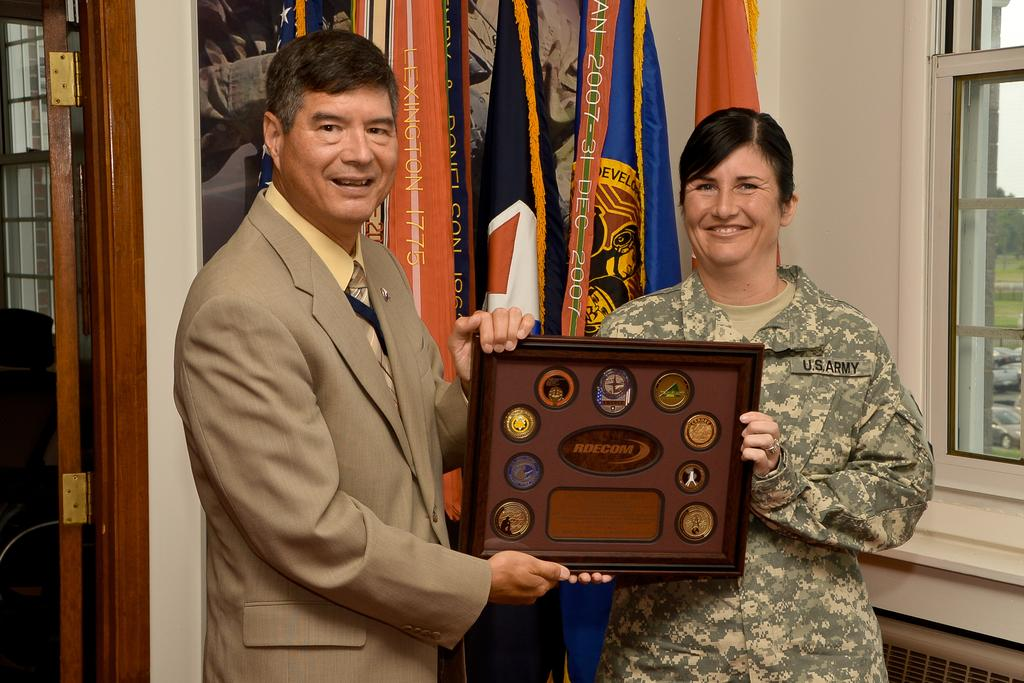How many people are present in the image? There are two people, a man and a woman, present in the image. What are the man and woman doing in the image? They are standing on the floor and holding a momento. What can be seen on the backside of the image? There are flags visible and a painting on a wall on the backside. Is there any architectural feature present in the image? Yes, there is a door in the image. What type of impulse can be seen affecting the weather in the image? There is no mention of weather or impulses in the image; it features a man and a woman holding a momento with flags and a painting visible in the background. 